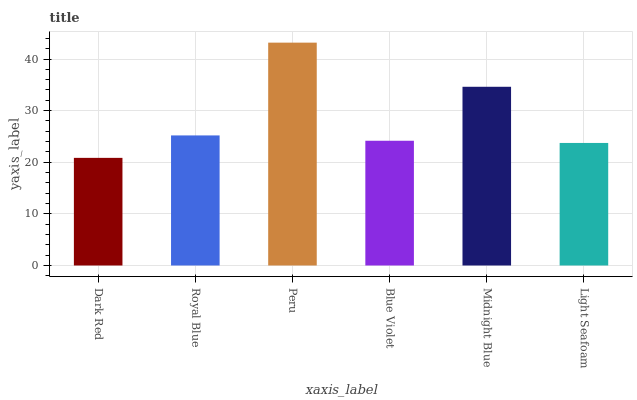Is Dark Red the minimum?
Answer yes or no. Yes. Is Peru the maximum?
Answer yes or no. Yes. Is Royal Blue the minimum?
Answer yes or no. No. Is Royal Blue the maximum?
Answer yes or no. No. Is Royal Blue greater than Dark Red?
Answer yes or no. Yes. Is Dark Red less than Royal Blue?
Answer yes or no. Yes. Is Dark Red greater than Royal Blue?
Answer yes or no. No. Is Royal Blue less than Dark Red?
Answer yes or no. No. Is Royal Blue the high median?
Answer yes or no. Yes. Is Blue Violet the low median?
Answer yes or no. Yes. Is Light Seafoam the high median?
Answer yes or no. No. Is Light Seafoam the low median?
Answer yes or no. No. 